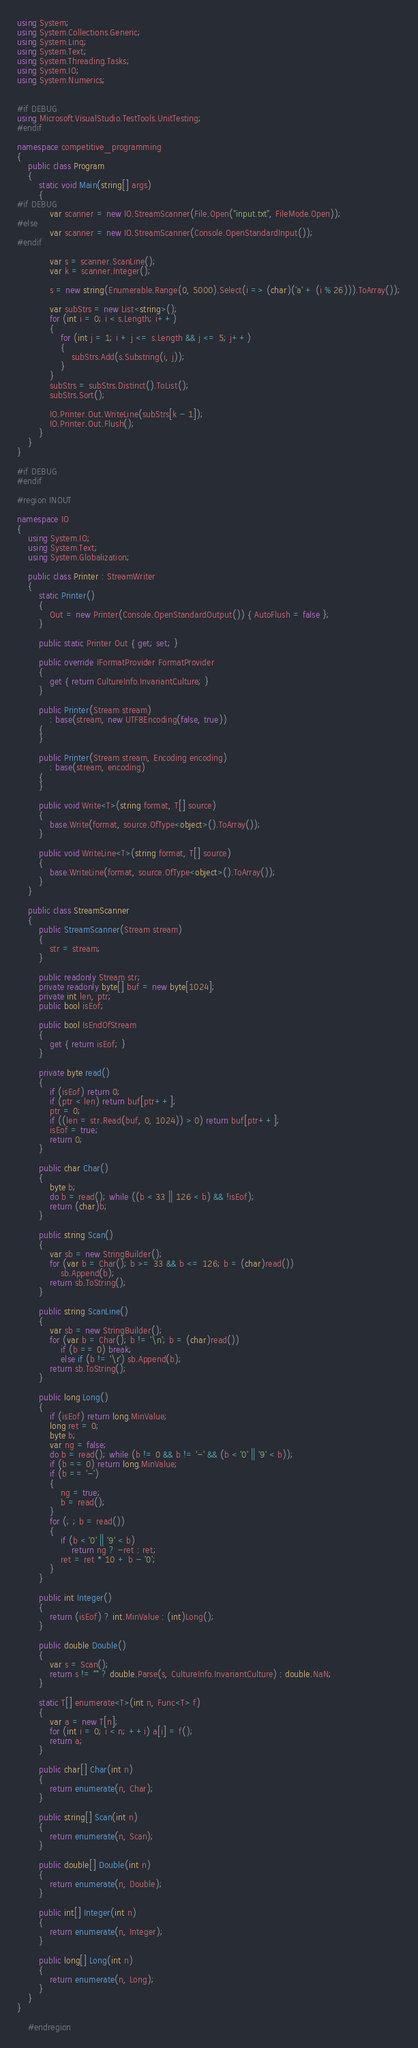<code> <loc_0><loc_0><loc_500><loc_500><_C#_>using System;
using System.Collections.Generic;
using System.Linq;
using System.Text;
using System.Threading.Tasks;
using System.IO;
using System.Numerics;


#if DEBUG
using Microsoft.VisualStudio.TestTools.UnitTesting;
#endif

namespace competitive_programming
{
    public class Program
    {
        static void Main(string[] args)
        {
#if DEBUG
            var scanner = new IO.StreamScanner(File.Open("input.txt", FileMode.Open));
#else
            var scanner = new IO.StreamScanner(Console.OpenStandardInput());
#endif

            var s = scanner.ScanLine();
            var k = scanner.Integer();

            s = new string(Enumerable.Range(0, 5000).Select(i => (char)('a' + (i % 26))).ToArray());

            var subStrs = new List<string>();
            for (int i = 0; i < s.Length; i++)
            {
                for (int j = 1; i + j <= s.Length && j <= 5; j++)
                {
                    subStrs.Add(s.Substring(i, j));
                }
            }
            subStrs = subStrs.Distinct().ToList();
            subStrs.Sort();

            IO.Printer.Out.WriteLine(subStrs[k - 1]);
            IO.Printer.Out.Flush();
        }
    }
}

#if DEBUG
#endif

#region INOUT

namespace IO
{
    using System.IO;
    using System.Text;
    using System.Globalization;

    public class Printer : StreamWriter
    {
        static Printer()
        {
            Out = new Printer(Console.OpenStandardOutput()) { AutoFlush = false };
        }

        public static Printer Out { get; set; }

        public override IFormatProvider FormatProvider
        {
            get { return CultureInfo.InvariantCulture; }
        }

        public Printer(Stream stream)
            : base(stream, new UTF8Encoding(false, true))
        {
        }

        public Printer(Stream stream, Encoding encoding)
            : base(stream, encoding)
        {
        }

        public void Write<T>(string format, T[] source)
        {
            base.Write(format, source.OfType<object>().ToArray());
        }

        public void WriteLine<T>(string format, T[] source)
        {
            base.WriteLine(format, source.OfType<object>().ToArray());
        }
    }

    public class StreamScanner
    {
        public StreamScanner(Stream stream)
        {
            str = stream;
        }

        public readonly Stream str;
        private readonly byte[] buf = new byte[1024];
        private int len, ptr;
        public bool isEof;

        public bool IsEndOfStream
        {
            get { return isEof; }
        }

        private byte read()
        {
            if (isEof) return 0;
            if (ptr < len) return buf[ptr++];
            ptr = 0;
            if ((len = str.Read(buf, 0, 1024)) > 0) return buf[ptr++];
            isEof = true;
            return 0;
        }

        public char Char()
        {
            byte b;
            do b = read(); while ((b < 33 || 126 < b) && !isEof);
            return (char)b;
        }

        public string Scan()
        {
            var sb = new StringBuilder();
            for (var b = Char(); b >= 33 && b <= 126; b = (char)read())
                sb.Append(b);
            return sb.ToString();
        }

        public string ScanLine()
        {
            var sb = new StringBuilder();
            for (var b = Char(); b != '\n'; b = (char)read())
                if (b == 0) break;
                else if (b != '\r') sb.Append(b);
            return sb.ToString();
        }

        public long Long()
        {
            if (isEof) return long.MinValue;
            long ret = 0;
            byte b;
            var ng = false;
            do b = read(); while (b != 0 && b != '-' && (b < '0' || '9' < b));
            if (b == 0) return long.MinValue;
            if (b == '-')
            {
                ng = true;
                b = read();
            }
            for (; ; b = read())
            {
                if (b < '0' || '9' < b)
                    return ng ? -ret : ret;
                ret = ret * 10 + b - '0';
            }
        }

        public int Integer()
        {
            return (isEof) ? int.MinValue : (int)Long();
        }

        public double Double()
        {
            var s = Scan();
            return s != "" ? double.Parse(s, CultureInfo.InvariantCulture) : double.NaN;
        }

        static T[] enumerate<T>(int n, Func<T> f)
        {
            var a = new T[n];
            for (int i = 0; i < n; ++i) a[i] = f();
            return a;
        }

        public char[] Char(int n)
        {
            return enumerate(n, Char);
        }

        public string[] Scan(int n)
        {
            return enumerate(n, Scan);
        }

        public double[] Double(int n)
        {
            return enumerate(n, Double);
        }

        public int[] Integer(int n)
        {
            return enumerate(n, Integer);
        }

        public long[] Long(int n)
        {
            return enumerate(n, Long);
        }
    }
}

    #endregion</code> 